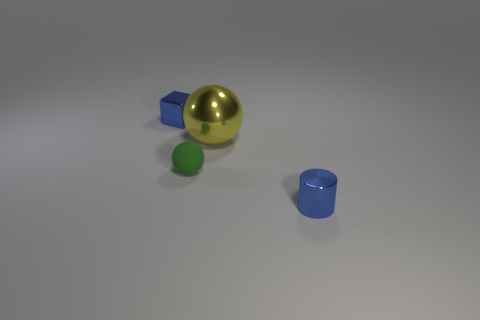Add 1 tiny blue metal objects. How many objects exist? 5 Subtract all cylinders. How many objects are left? 3 Subtract all small red metal spheres. Subtract all blue shiny cylinders. How many objects are left? 3 Add 2 yellow metallic things. How many yellow metallic things are left? 3 Add 4 blue cylinders. How many blue cylinders exist? 5 Subtract 0 brown blocks. How many objects are left? 4 